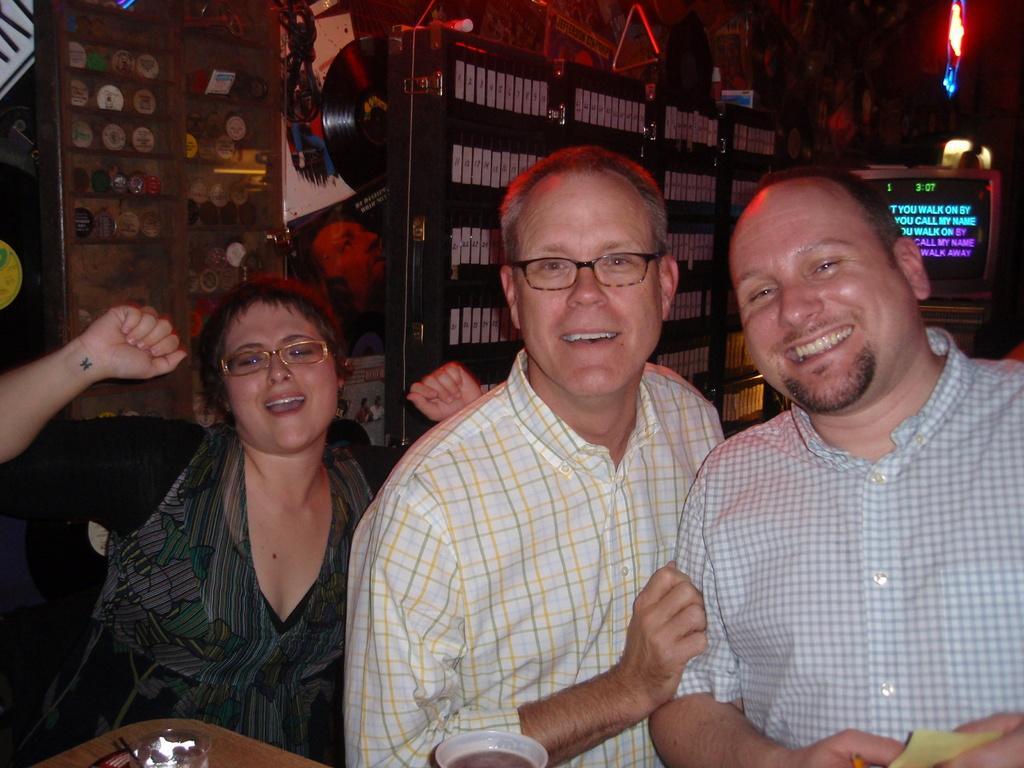Describe this image in one or two sentences. In this picture we can see three people and they are smiling and in the background we can see a screen and some objects. 